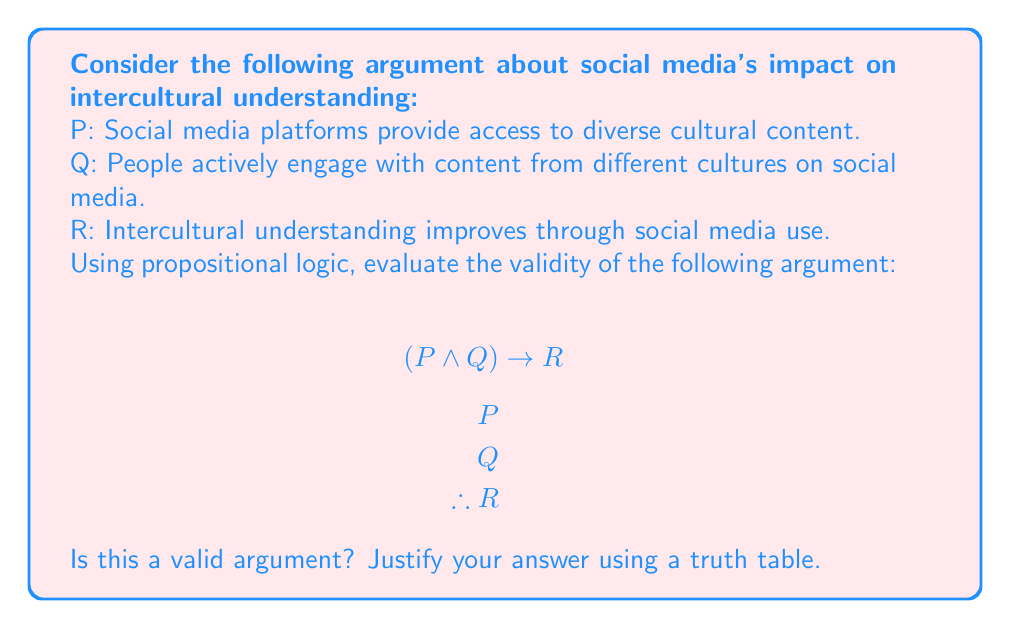Could you help me with this problem? To evaluate the validity of this argument using propositional logic, we need to construct a truth table for the given premises and conclusion. An argument is considered valid if the conclusion is true whenever all the premises are true.

Let's create a truth table for $(P \wedge Q) \rightarrow R$, $P$, $Q$, and $R$:

$$\begin{array}{|c|c|c|c|c|c|}
\hline
P & Q & R & P \wedge Q & (P \wedge Q) \rightarrow R & \text{Valid?} \\
\hline
T & T & T & T & T & \text{Yes} \\
T & T & F & T & F & \text{No} \\
T & F & T & F & T & \text{Yes} \\
T & F & F & F & T & \text{Yes} \\
F & T & T & F & T & \text{Yes} \\
F & T & F & F & T & \text{Yes} \\
F & F & T & F & T & \text{Yes} \\
F & F & F & F & T & \text{Yes} \\
\hline
\end{array}$$

In this truth table:
1. We list all possible combinations of truth values for $P$, $Q$, and $R$.
2. We evaluate $P \wedge Q$.
3. We evaluate $(P \wedge Q) \rightarrow R$.
4. We check if the argument is valid for each row.

An argument is valid if, whenever all premises are true, the conclusion is also true. In this case, we need to look at rows where both $P$ and $Q$ are true (the first two rows), as these represent the given premises.

We can see that in the first row, where $P$, $Q$, and $R$ are all true, the argument is valid. However, in the second row, where $P$ and $Q$ are true but $R$ is false, the argument is not valid.

This means that it's possible for the premises to be true (social media provides access to diverse cultural content and people actively engage with it) while the conclusion is false (intercultural understanding does not improve).
Answer: The argument is not valid. The truth table shows that there exists a case (row 2) where both premises $P$ and $Q$ are true, but the conclusion $R$ is false. This demonstrates that the given argument form does not guarantee the truth of the conclusion when the premises are true, making it an invalid argument in propositional logic. 